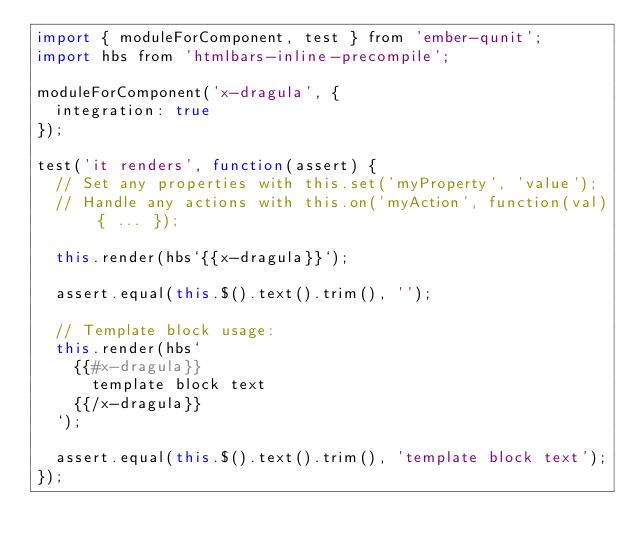Convert code to text. <code><loc_0><loc_0><loc_500><loc_500><_JavaScript_>import { moduleForComponent, test } from 'ember-qunit';
import hbs from 'htmlbars-inline-precompile';

moduleForComponent('x-dragula', {
  integration: true
});

test('it renders', function(assert) {
  // Set any properties with this.set('myProperty', 'value');
  // Handle any actions with this.on('myAction', function(val) { ... });

  this.render(hbs`{{x-dragula}}`);

  assert.equal(this.$().text().trim(), '');

  // Template block usage:
  this.render(hbs`
    {{#x-dragula}}
      template block text
    {{/x-dragula}}
  `);

  assert.equal(this.$().text().trim(), 'template block text');
});
</code> 